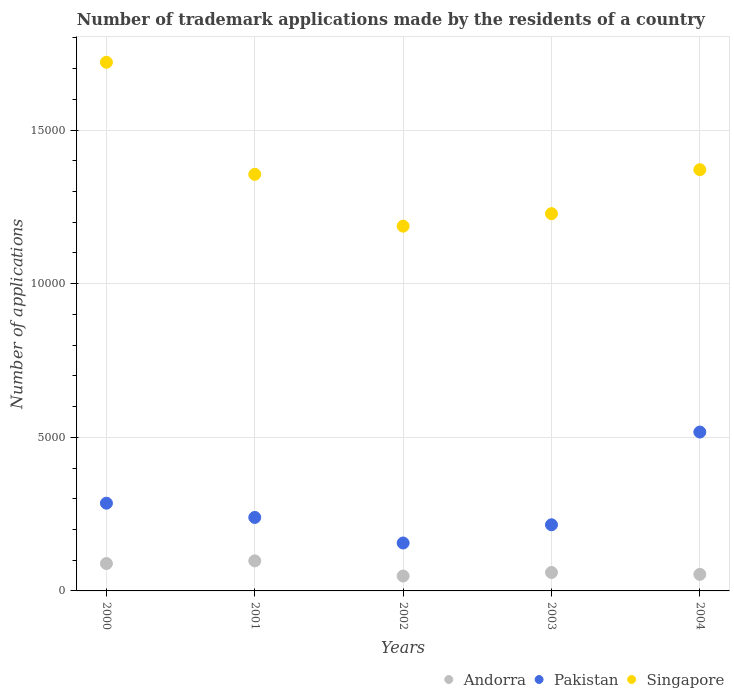What is the number of trademark applications made by the residents in Andorra in 2002?
Offer a terse response. 485. Across all years, what is the maximum number of trademark applications made by the residents in Pakistan?
Offer a terse response. 5171. Across all years, what is the minimum number of trademark applications made by the residents in Singapore?
Your response must be concise. 1.19e+04. In which year was the number of trademark applications made by the residents in Pakistan maximum?
Give a very brief answer. 2004. In which year was the number of trademark applications made by the residents in Pakistan minimum?
Make the answer very short. 2002. What is the total number of trademark applications made by the residents in Singapore in the graph?
Make the answer very short. 6.86e+04. What is the difference between the number of trademark applications made by the residents in Pakistan in 2001 and that in 2002?
Keep it short and to the point. 832. What is the difference between the number of trademark applications made by the residents in Pakistan in 2004 and the number of trademark applications made by the residents in Singapore in 2001?
Give a very brief answer. -8388. What is the average number of trademark applications made by the residents in Singapore per year?
Provide a short and direct response. 1.37e+04. In the year 2003, what is the difference between the number of trademark applications made by the residents in Andorra and number of trademark applications made by the residents in Singapore?
Offer a very short reply. -1.17e+04. In how many years, is the number of trademark applications made by the residents in Andorra greater than 5000?
Your response must be concise. 0. What is the ratio of the number of trademark applications made by the residents in Pakistan in 2000 to that in 2002?
Provide a short and direct response. 1.83. What is the difference between the highest and the second highest number of trademark applications made by the residents in Singapore?
Keep it short and to the point. 3496. What is the difference between the highest and the lowest number of trademark applications made by the residents in Andorra?
Your answer should be compact. 493. Is the sum of the number of trademark applications made by the residents in Singapore in 2001 and 2002 greater than the maximum number of trademark applications made by the residents in Andorra across all years?
Make the answer very short. Yes. How many dotlines are there?
Offer a terse response. 3. What is the difference between two consecutive major ticks on the Y-axis?
Ensure brevity in your answer.  5000. Are the values on the major ticks of Y-axis written in scientific E-notation?
Give a very brief answer. No. Does the graph contain grids?
Your answer should be very brief. Yes. Where does the legend appear in the graph?
Provide a succinct answer. Bottom right. How many legend labels are there?
Give a very brief answer. 3. How are the legend labels stacked?
Your answer should be compact. Horizontal. What is the title of the graph?
Your response must be concise. Number of trademark applications made by the residents of a country. What is the label or title of the Y-axis?
Provide a short and direct response. Number of applications. What is the Number of applications in Andorra in 2000?
Offer a terse response. 892. What is the Number of applications of Pakistan in 2000?
Provide a short and direct response. 2855. What is the Number of applications in Singapore in 2000?
Keep it short and to the point. 1.72e+04. What is the Number of applications in Andorra in 2001?
Offer a very short reply. 978. What is the Number of applications of Pakistan in 2001?
Keep it short and to the point. 2392. What is the Number of applications in Singapore in 2001?
Provide a succinct answer. 1.36e+04. What is the Number of applications in Andorra in 2002?
Your response must be concise. 485. What is the Number of applications in Pakistan in 2002?
Keep it short and to the point. 1560. What is the Number of applications in Singapore in 2002?
Make the answer very short. 1.19e+04. What is the Number of applications in Andorra in 2003?
Give a very brief answer. 601. What is the Number of applications of Pakistan in 2003?
Make the answer very short. 2153. What is the Number of applications in Singapore in 2003?
Your answer should be compact. 1.23e+04. What is the Number of applications in Andorra in 2004?
Give a very brief answer. 539. What is the Number of applications of Pakistan in 2004?
Your answer should be very brief. 5171. What is the Number of applications of Singapore in 2004?
Your answer should be compact. 1.37e+04. Across all years, what is the maximum Number of applications in Andorra?
Make the answer very short. 978. Across all years, what is the maximum Number of applications of Pakistan?
Offer a terse response. 5171. Across all years, what is the maximum Number of applications in Singapore?
Give a very brief answer. 1.72e+04. Across all years, what is the minimum Number of applications of Andorra?
Your answer should be very brief. 485. Across all years, what is the minimum Number of applications in Pakistan?
Make the answer very short. 1560. Across all years, what is the minimum Number of applications in Singapore?
Ensure brevity in your answer.  1.19e+04. What is the total Number of applications of Andorra in the graph?
Give a very brief answer. 3495. What is the total Number of applications in Pakistan in the graph?
Your answer should be compact. 1.41e+04. What is the total Number of applications in Singapore in the graph?
Give a very brief answer. 6.86e+04. What is the difference between the Number of applications in Andorra in 2000 and that in 2001?
Ensure brevity in your answer.  -86. What is the difference between the Number of applications of Pakistan in 2000 and that in 2001?
Your answer should be very brief. 463. What is the difference between the Number of applications of Singapore in 2000 and that in 2001?
Keep it short and to the point. 3648. What is the difference between the Number of applications in Andorra in 2000 and that in 2002?
Offer a terse response. 407. What is the difference between the Number of applications in Pakistan in 2000 and that in 2002?
Your answer should be very brief. 1295. What is the difference between the Number of applications of Singapore in 2000 and that in 2002?
Your answer should be compact. 5335. What is the difference between the Number of applications of Andorra in 2000 and that in 2003?
Provide a short and direct response. 291. What is the difference between the Number of applications of Pakistan in 2000 and that in 2003?
Give a very brief answer. 702. What is the difference between the Number of applications in Singapore in 2000 and that in 2003?
Your answer should be very brief. 4928. What is the difference between the Number of applications of Andorra in 2000 and that in 2004?
Your answer should be compact. 353. What is the difference between the Number of applications in Pakistan in 2000 and that in 2004?
Provide a succinct answer. -2316. What is the difference between the Number of applications in Singapore in 2000 and that in 2004?
Your answer should be very brief. 3496. What is the difference between the Number of applications in Andorra in 2001 and that in 2002?
Offer a terse response. 493. What is the difference between the Number of applications in Pakistan in 2001 and that in 2002?
Ensure brevity in your answer.  832. What is the difference between the Number of applications of Singapore in 2001 and that in 2002?
Offer a terse response. 1687. What is the difference between the Number of applications of Andorra in 2001 and that in 2003?
Your answer should be very brief. 377. What is the difference between the Number of applications of Pakistan in 2001 and that in 2003?
Make the answer very short. 239. What is the difference between the Number of applications in Singapore in 2001 and that in 2003?
Give a very brief answer. 1280. What is the difference between the Number of applications of Andorra in 2001 and that in 2004?
Keep it short and to the point. 439. What is the difference between the Number of applications in Pakistan in 2001 and that in 2004?
Your response must be concise. -2779. What is the difference between the Number of applications of Singapore in 2001 and that in 2004?
Keep it short and to the point. -152. What is the difference between the Number of applications in Andorra in 2002 and that in 2003?
Your answer should be very brief. -116. What is the difference between the Number of applications in Pakistan in 2002 and that in 2003?
Offer a very short reply. -593. What is the difference between the Number of applications of Singapore in 2002 and that in 2003?
Offer a very short reply. -407. What is the difference between the Number of applications of Andorra in 2002 and that in 2004?
Ensure brevity in your answer.  -54. What is the difference between the Number of applications in Pakistan in 2002 and that in 2004?
Give a very brief answer. -3611. What is the difference between the Number of applications in Singapore in 2002 and that in 2004?
Your answer should be compact. -1839. What is the difference between the Number of applications of Pakistan in 2003 and that in 2004?
Make the answer very short. -3018. What is the difference between the Number of applications of Singapore in 2003 and that in 2004?
Make the answer very short. -1432. What is the difference between the Number of applications in Andorra in 2000 and the Number of applications in Pakistan in 2001?
Give a very brief answer. -1500. What is the difference between the Number of applications in Andorra in 2000 and the Number of applications in Singapore in 2001?
Offer a very short reply. -1.27e+04. What is the difference between the Number of applications of Pakistan in 2000 and the Number of applications of Singapore in 2001?
Your response must be concise. -1.07e+04. What is the difference between the Number of applications of Andorra in 2000 and the Number of applications of Pakistan in 2002?
Ensure brevity in your answer.  -668. What is the difference between the Number of applications of Andorra in 2000 and the Number of applications of Singapore in 2002?
Provide a succinct answer. -1.10e+04. What is the difference between the Number of applications of Pakistan in 2000 and the Number of applications of Singapore in 2002?
Your answer should be very brief. -9017. What is the difference between the Number of applications of Andorra in 2000 and the Number of applications of Pakistan in 2003?
Keep it short and to the point. -1261. What is the difference between the Number of applications in Andorra in 2000 and the Number of applications in Singapore in 2003?
Your response must be concise. -1.14e+04. What is the difference between the Number of applications in Pakistan in 2000 and the Number of applications in Singapore in 2003?
Give a very brief answer. -9424. What is the difference between the Number of applications of Andorra in 2000 and the Number of applications of Pakistan in 2004?
Offer a terse response. -4279. What is the difference between the Number of applications in Andorra in 2000 and the Number of applications in Singapore in 2004?
Provide a short and direct response. -1.28e+04. What is the difference between the Number of applications of Pakistan in 2000 and the Number of applications of Singapore in 2004?
Provide a succinct answer. -1.09e+04. What is the difference between the Number of applications of Andorra in 2001 and the Number of applications of Pakistan in 2002?
Offer a terse response. -582. What is the difference between the Number of applications in Andorra in 2001 and the Number of applications in Singapore in 2002?
Your response must be concise. -1.09e+04. What is the difference between the Number of applications of Pakistan in 2001 and the Number of applications of Singapore in 2002?
Provide a succinct answer. -9480. What is the difference between the Number of applications in Andorra in 2001 and the Number of applications in Pakistan in 2003?
Provide a succinct answer. -1175. What is the difference between the Number of applications of Andorra in 2001 and the Number of applications of Singapore in 2003?
Offer a very short reply. -1.13e+04. What is the difference between the Number of applications of Pakistan in 2001 and the Number of applications of Singapore in 2003?
Offer a very short reply. -9887. What is the difference between the Number of applications of Andorra in 2001 and the Number of applications of Pakistan in 2004?
Provide a short and direct response. -4193. What is the difference between the Number of applications of Andorra in 2001 and the Number of applications of Singapore in 2004?
Keep it short and to the point. -1.27e+04. What is the difference between the Number of applications of Pakistan in 2001 and the Number of applications of Singapore in 2004?
Make the answer very short. -1.13e+04. What is the difference between the Number of applications in Andorra in 2002 and the Number of applications in Pakistan in 2003?
Provide a succinct answer. -1668. What is the difference between the Number of applications in Andorra in 2002 and the Number of applications in Singapore in 2003?
Give a very brief answer. -1.18e+04. What is the difference between the Number of applications in Pakistan in 2002 and the Number of applications in Singapore in 2003?
Ensure brevity in your answer.  -1.07e+04. What is the difference between the Number of applications of Andorra in 2002 and the Number of applications of Pakistan in 2004?
Your answer should be compact. -4686. What is the difference between the Number of applications of Andorra in 2002 and the Number of applications of Singapore in 2004?
Your answer should be compact. -1.32e+04. What is the difference between the Number of applications of Pakistan in 2002 and the Number of applications of Singapore in 2004?
Provide a short and direct response. -1.22e+04. What is the difference between the Number of applications in Andorra in 2003 and the Number of applications in Pakistan in 2004?
Ensure brevity in your answer.  -4570. What is the difference between the Number of applications of Andorra in 2003 and the Number of applications of Singapore in 2004?
Keep it short and to the point. -1.31e+04. What is the difference between the Number of applications of Pakistan in 2003 and the Number of applications of Singapore in 2004?
Provide a succinct answer. -1.16e+04. What is the average Number of applications in Andorra per year?
Offer a terse response. 699. What is the average Number of applications of Pakistan per year?
Provide a succinct answer. 2826.2. What is the average Number of applications of Singapore per year?
Your answer should be very brief. 1.37e+04. In the year 2000, what is the difference between the Number of applications in Andorra and Number of applications in Pakistan?
Offer a very short reply. -1963. In the year 2000, what is the difference between the Number of applications of Andorra and Number of applications of Singapore?
Ensure brevity in your answer.  -1.63e+04. In the year 2000, what is the difference between the Number of applications of Pakistan and Number of applications of Singapore?
Provide a short and direct response. -1.44e+04. In the year 2001, what is the difference between the Number of applications of Andorra and Number of applications of Pakistan?
Give a very brief answer. -1414. In the year 2001, what is the difference between the Number of applications of Andorra and Number of applications of Singapore?
Offer a very short reply. -1.26e+04. In the year 2001, what is the difference between the Number of applications in Pakistan and Number of applications in Singapore?
Give a very brief answer. -1.12e+04. In the year 2002, what is the difference between the Number of applications of Andorra and Number of applications of Pakistan?
Keep it short and to the point. -1075. In the year 2002, what is the difference between the Number of applications in Andorra and Number of applications in Singapore?
Keep it short and to the point. -1.14e+04. In the year 2002, what is the difference between the Number of applications of Pakistan and Number of applications of Singapore?
Make the answer very short. -1.03e+04. In the year 2003, what is the difference between the Number of applications of Andorra and Number of applications of Pakistan?
Make the answer very short. -1552. In the year 2003, what is the difference between the Number of applications of Andorra and Number of applications of Singapore?
Provide a short and direct response. -1.17e+04. In the year 2003, what is the difference between the Number of applications in Pakistan and Number of applications in Singapore?
Offer a terse response. -1.01e+04. In the year 2004, what is the difference between the Number of applications in Andorra and Number of applications in Pakistan?
Your answer should be very brief. -4632. In the year 2004, what is the difference between the Number of applications of Andorra and Number of applications of Singapore?
Offer a terse response. -1.32e+04. In the year 2004, what is the difference between the Number of applications in Pakistan and Number of applications in Singapore?
Keep it short and to the point. -8540. What is the ratio of the Number of applications in Andorra in 2000 to that in 2001?
Offer a terse response. 0.91. What is the ratio of the Number of applications of Pakistan in 2000 to that in 2001?
Make the answer very short. 1.19. What is the ratio of the Number of applications of Singapore in 2000 to that in 2001?
Ensure brevity in your answer.  1.27. What is the ratio of the Number of applications in Andorra in 2000 to that in 2002?
Your answer should be compact. 1.84. What is the ratio of the Number of applications in Pakistan in 2000 to that in 2002?
Your answer should be very brief. 1.83. What is the ratio of the Number of applications of Singapore in 2000 to that in 2002?
Provide a succinct answer. 1.45. What is the ratio of the Number of applications in Andorra in 2000 to that in 2003?
Give a very brief answer. 1.48. What is the ratio of the Number of applications in Pakistan in 2000 to that in 2003?
Your response must be concise. 1.33. What is the ratio of the Number of applications of Singapore in 2000 to that in 2003?
Make the answer very short. 1.4. What is the ratio of the Number of applications in Andorra in 2000 to that in 2004?
Give a very brief answer. 1.65. What is the ratio of the Number of applications of Pakistan in 2000 to that in 2004?
Provide a short and direct response. 0.55. What is the ratio of the Number of applications in Singapore in 2000 to that in 2004?
Make the answer very short. 1.25. What is the ratio of the Number of applications of Andorra in 2001 to that in 2002?
Your answer should be very brief. 2.02. What is the ratio of the Number of applications in Pakistan in 2001 to that in 2002?
Provide a short and direct response. 1.53. What is the ratio of the Number of applications of Singapore in 2001 to that in 2002?
Make the answer very short. 1.14. What is the ratio of the Number of applications of Andorra in 2001 to that in 2003?
Keep it short and to the point. 1.63. What is the ratio of the Number of applications of Pakistan in 2001 to that in 2003?
Your answer should be very brief. 1.11. What is the ratio of the Number of applications of Singapore in 2001 to that in 2003?
Give a very brief answer. 1.1. What is the ratio of the Number of applications in Andorra in 2001 to that in 2004?
Your response must be concise. 1.81. What is the ratio of the Number of applications in Pakistan in 2001 to that in 2004?
Offer a very short reply. 0.46. What is the ratio of the Number of applications of Singapore in 2001 to that in 2004?
Give a very brief answer. 0.99. What is the ratio of the Number of applications in Andorra in 2002 to that in 2003?
Give a very brief answer. 0.81. What is the ratio of the Number of applications of Pakistan in 2002 to that in 2003?
Your response must be concise. 0.72. What is the ratio of the Number of applications in Singapore in 2002 to that in 2003?
Make the answer very short. 0.97. What is the ratio of the Number of applications of Andorra in 2002 to that in 2004?
Keep it short and to the point. 0.9. What is the ratio of the Number of applications of Pakistan in 2002 to that in 2004?
Make the answer very short. 0.3. What is the ratio of the Number of applications in Singapore in 2002 to that in 2004?
Your answer should be very brief. 0.87. What is the ratio of the Number of applications of Andorra in 2003 to that in 2004?
Provide a succinct answer. 1.11. What is the ratio of the Number of applications of Pakistan in 2003 to that in 2004?
Your response must be concise. 0.42. What is the ratio of the Number of applications in Singapore in 2003 to that in 2004?
Provide a succinct answer. 0.9. What is the difference between the highest and the second highest Number of applications in Andorra?
Offer a very short reply. 86. What is the difference between the highest and the second highest Number of applications in Pakistan?
Your answer should be very brief. 2316. What is the difference between the highest and the second highest Number of applications in Singapore?
Give a very brief answer. 3496. What is the difference between the highest and the lowest Number of applications in Andorra?
Ensure brevity in your answer.  493. What is the difference between the highest and the lowest Number of applications in Pakistan?
Offer a terse response. 3611. What is the difference between the highest and the lowest Number of applications in Singapore?
Your answer should be very brief. 5335. 